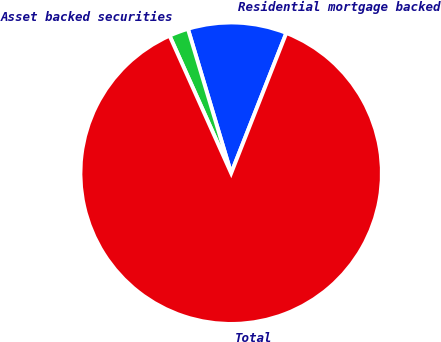Convert chart. <chart><loc_0><loc_0><loc_500><loc_500><pie_chart><fcel>Residential mortgage backed<fcel>Asset backed securities<fcel>Total<nl><fcel>10.6%<fcel>2.07%<fcel>87.34%<nl></chart> 